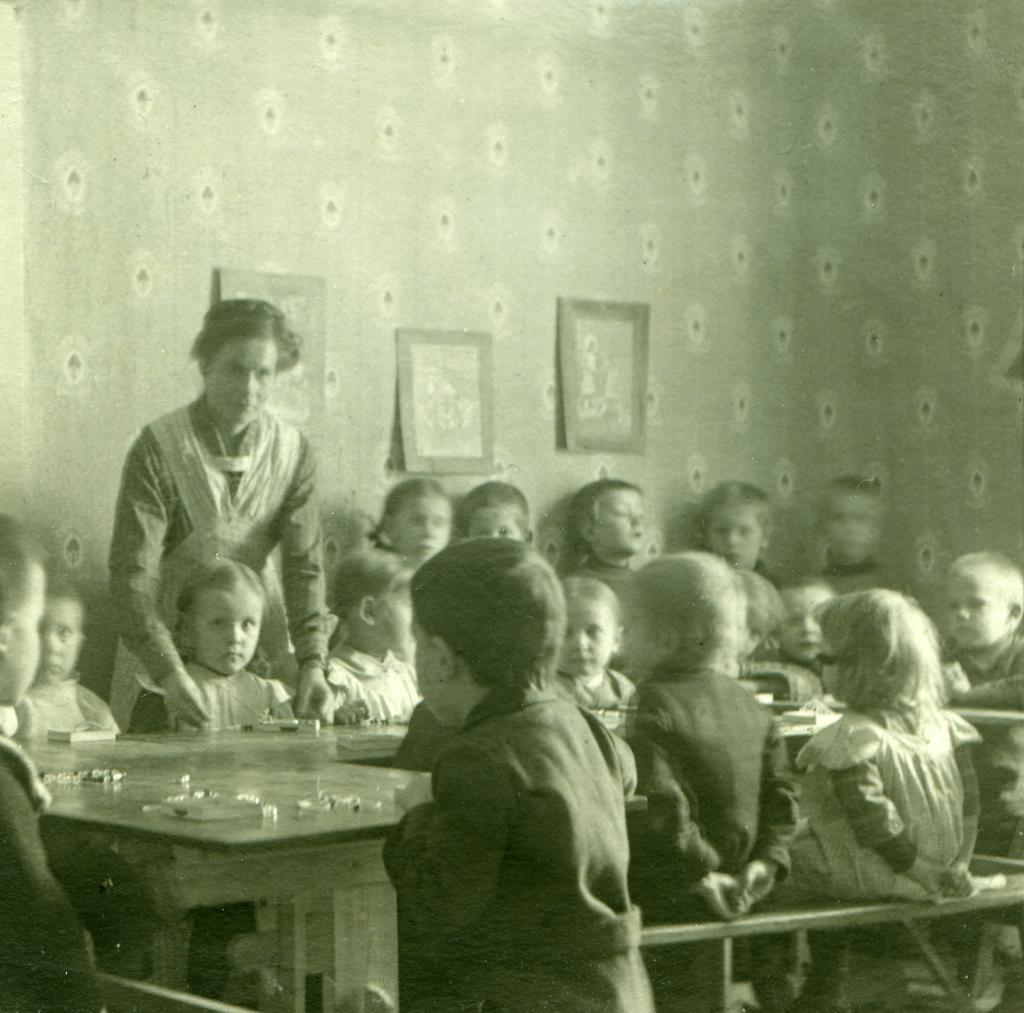How many people are in the image? There are many children in the image. What are the children doing in the image? The children are sitting around a table. How many passengers are sitting on the chicken in the image? There are no passengers or chickens present in the image; it features many children sitting around a table. 